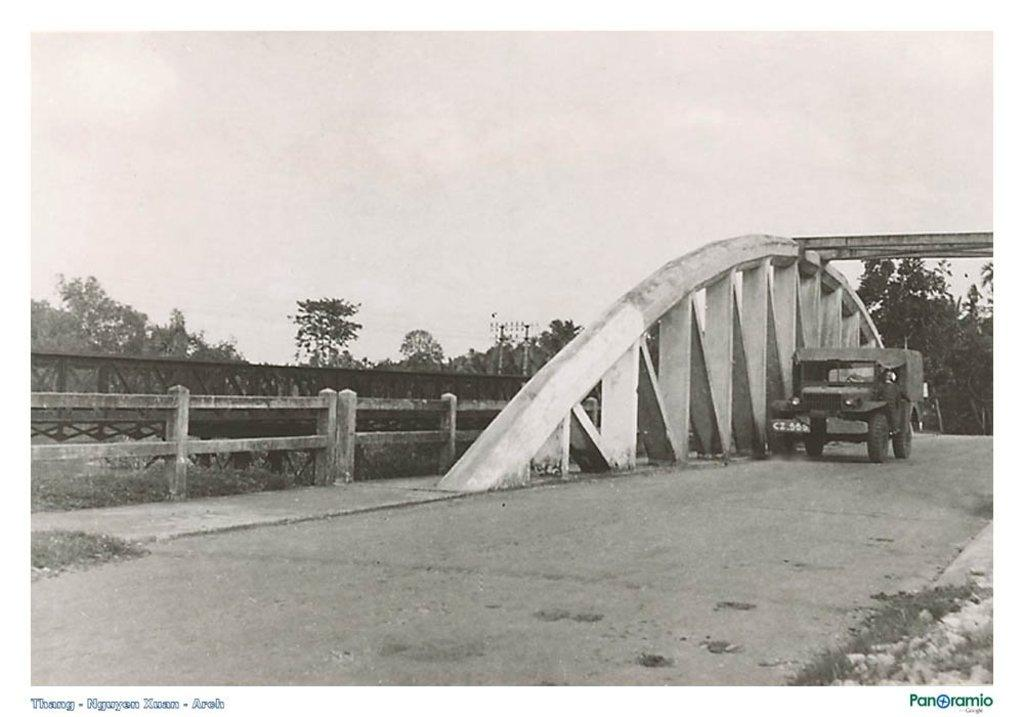What is the color scheme of the image? The image is black and white. What can be seen on the road in the image? There is a vehicle on the road in the image. What type of natural elements are visible in the background? There are trees in the background of the image. What architectural feature can be seen in the background? There is a fence in the background of the image. Where is the throne located in the image? There is no throne present in the image. Can you see any magic happening in the image? There is no magic present in the image. 